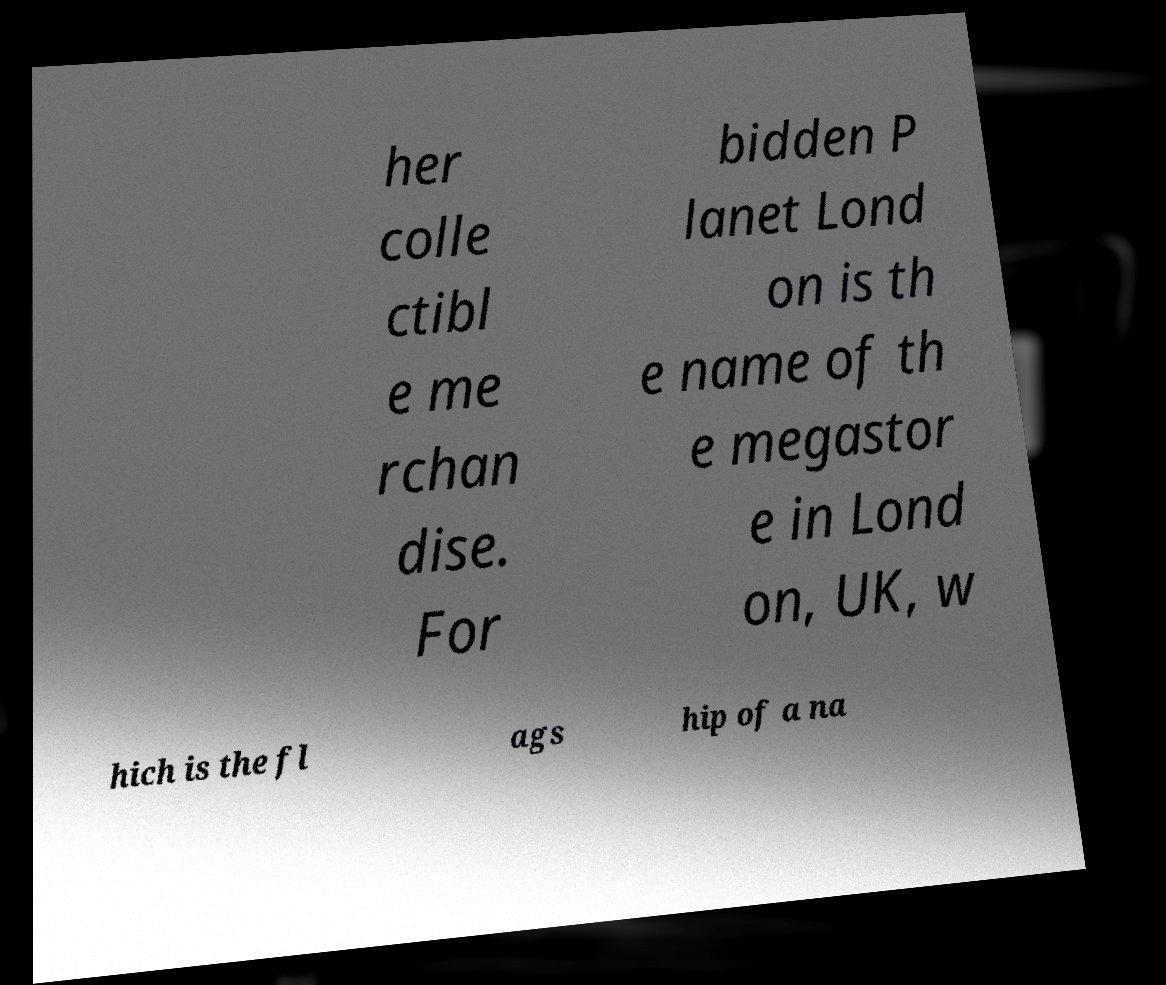Could you assist in decoding the text presented in this image and type it out clearly? her colle ctibl e me rchan dise. For bidden P lanet Lond on is th e name of th e megastor e in Lond on, UK, w hich is the fl ags hip of a na 